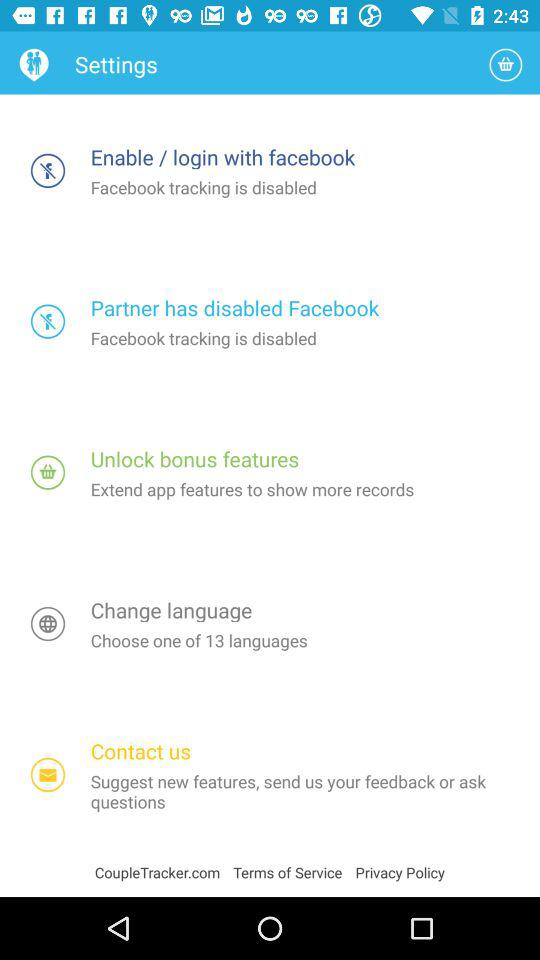How many of the settings options are about Facebook?
Answer the question using a single word or phrase. 2 